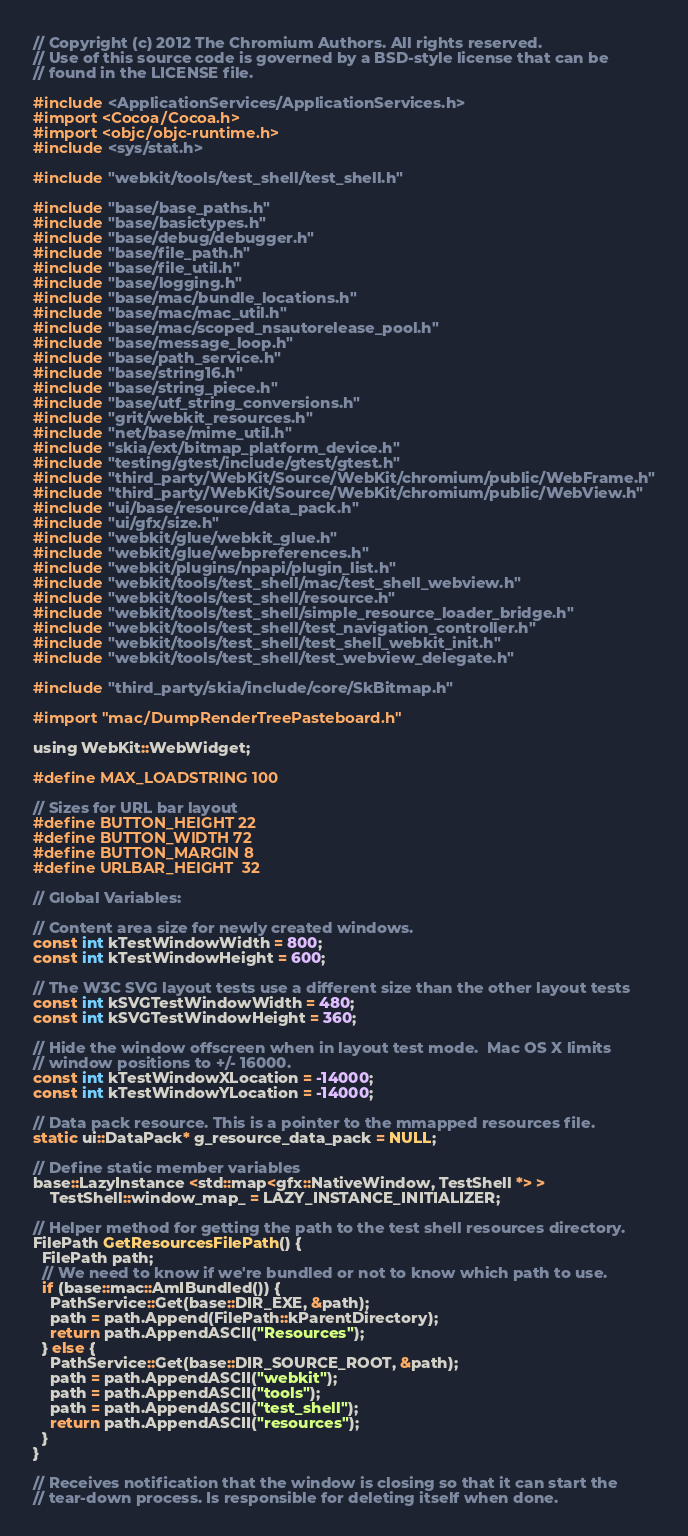Convert code to text. <code><loc_0><loc_0><loc_500><loc_500><_ObjectiveC_>// Copyright (c) 2012 The Chromium Authors. All rights reserved.
// Use of this source code is governed by a BSD-style license that can be
// found in the LICENSE file.

#include <ApplicationServices/ApplicationServices.h>
#import <Cocoa/Cocoa.h>
#import <objc/objc-runtime.h>
#include <sys/stat.h>

#include "webkit/tools/test_shell/test_shell.h"

#include "base/base_paths.h"
#include "base/basictypes.h"
#include "base/debug/debugger.h"
#include "base/file_path.h"
#include "base/file_util.h"
#include "base/logging.h"
#include "base/mac/bundle_locations.h"
#include "base/mac/mac_util.h"
#include "base/mac/scoped_nsautorelease_pool.h"
#include "base/message_loop.h"
#include "base/path_service.h"
#include "base/string16.h"
#include "base/string_piece.h"
#include "base/utf_string_conversions.h"
#include "grit/webkit_resources.h"
#include "net/base/mime_util.h"
#include "skia/ext/bitmap_platform_device.h"
#include "testing/gtest/include/gtest/gtest.h"
#include "third_party/WebKit/Source/WebKit/chromium/public/WebFrame.h"
#include "third_party/WebKit/Source/WebKit/chromium/public/WebView.h"
#include "ui/base/resource/data_pack.h"
#include "ui/gfx/size.h"
#include "webkit/glue/webkit_glue.h"
#include "webkit/glue/webpreferences.h"
#include "webkit/plugins/npapi/plugin_list.h"
#include "webkit/tools/test_shell/mac/test_shell_webview.h"
#include "webkit/tools/test_shell/resource.h"
#include "webkit/tools/test_shell/simple_resource_loader_bridge.h"
#include "webkit/tools/test_shell/test_navigation_controller.h"
#include "webkit/tools/test_shell/test_shell_webkit_init.h"
#include "webkit/tools/test_shell/test_webview_delegate.h"

#include "third_party/skia/include/core/SkBitmap.h"

#import "mac/DumpRenderTreePasteboard.h"

using WebKit::WebWidget;

#define MAX_LOADSTRING 100

// Sizes for URL bar layout
#define BUTTON_HEIGHT 22
#define BUTTON_WIDTH 72
#define BUTTON_MARGIN 8
#define URLBAR_HEIGHT  32

// Global Variables:

// Content area size for newly created windows.
const int kTestWindowWidth = 800;
const int kTestWindowHeight = 600;

// The W3C SVG layout tests use a different size than the other layout tests
const int kSVGTestWindowWidth = 480;
const int kSVGTestWindowHeight = 360;

// Hide the window offscreen when in layout test mode.  Mac OS X limits
// window positions to +/- 16000.
const int kTestWindowXLocation = -14000;
const int kTestWindowYLocation = -14000;

// Data pack resource. This is a pointer to the mmapped resources file.
static ui::DataPack* g_resource_data_pack = NULL;

// Define static member variables
base::LazyInstance <std::map<gfx::NativeWindow, TestShell *> >
    TestShell::window_map_ = LAZY_INSTANCE_INITIALIZER;

// Helper method for getting the path to the test shell resources directory.
FilePath GetResourcesFilePath() {
  FilePath path;
  // We need to know if we're bundled or not to know which path to use.
  if (base::mac::AmIBundled()) {
    PathService::Get(base::DIR_EXE, &path);
    path = path.Append(FilePath::kParentDirectory);
    return path.AppendASCII("Resources");
  } else {
    PathService::Get(base::DIR_SOURCE_ROOT, &path);
    path = path.AppendASCII("webkit");
    path = path.AppendASCII("tools");
    path = path.AppendASCII("test_shell");
    return path.AppendASCII("resources");
  }
}

// Receives notification that the window is closing so that it can start the
// tear-down process. Is responsible for deleting itself when done.</code> 